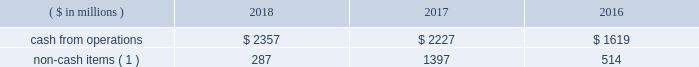We monitor the status of the capital markets and regularly evaluate the effect that changes in capital market conditions may have on our ability to execute our announced growth plans and fund our liquidity needs .
We expect to continue meeting part of our financing and liquidity needs primarily through commercial paper borrowings , issuances of senior notes , and access to long-term committed credit facilities .
If conditions in the lodging industry deteriorate , or if disruptions in the capital markets take place as they did in the immediate aftermath of both the 2008 worldwide financial crisis and the events of september 11 , 2001 , we may be unable to place some or all of our commercial paper on a temporary or extended basis and may have to rely more on borrowings under the credit facility , which we believe will be adequate to fund our liquidity needs , including repayment of debt obligations , but which may carry a higher cost than commercial paper .
Since we continue to have ample flexibility under the credit facility 2019s covenants , we expect that undrawn bank commitments under the credit facility will remain available to us even if business conditions were to deteriorate markedly .
Cash from operations cash from operations and non-cash items for the last three fiscal years are as follows: .
Non-cash items ( 1 ) 287 1397 514 ( 1 ) includes depreciation , amortization , share-based compensation , deferred income taxes , and contract investment amortization .
Our ratio of current assets to current liabilities was 0.4 to 1.0 at year-end 2018 and 0.5 to 1.0 at year-end 2017 .
We minimize working capital through cash management , strict credit-granting policies , and aggressive collection efforts .
We also have significant borrowing capacity under our credit facility should we need additional working capital .
Investing activities cash flows acquisition of a business , net of cash acquired .
Cash outflows of $ 2392 million in 2016 were due to the starwood combination .
See footnote 3 .
Dispositions and acquisitions for more information .
Capital expenditures and other investments .
We made capital expenditures of $ 556 million in 2018 , $ 240 million in 2017 , and $ 199 million in 2016 .
Capital expenditures in 2018 increased by $ 316 million compared to 2017 , primarily reflecting the acquisition of the sheraton grand phoenix , improvements to our worldwide systems , and net higher spending on several owned properties .
Capital expenditures in 2017 increased by $ 41 million compared to 2016 , primarily due to improvements to our worldwide systems and improvements to hotels acquired in the starwood combination .
We expect spending on capital expenditures and other investments will total approximately $ 500 million to $ 700 million for 2019 , including acquisitions , loan advances , equity and other investments , contract acquisition costs , and various capital expenditures ( including approximately $ 225 million for maintenance capital spending ) .
Over time , we have sold lodging properties , both completed and under development , subject to long-term management agreements .
The ability of third-party purchasers to raise the debt and equity capital necessary to acquire such properties depends in part on the perceived risks in the lodging industry and other constraints inherent in the capital markets .
We monitor the status of the capital markets and regularly evaluate the potential impact of changes in capital market conditions on our business operations .
In the starwood combination , we acquired various hotels and joint venture interests in hotels , most of which we have sold or are seeking to sell , and in 2018 , we acquired the sheraton grand phoenix , which we expect to renovate and sell subject to a long-term management agreement .
We also expect to continue making selective and opportunistic investments to add units to our lodging business , which may include property acquisitions , new construction , loans , guarantees , and noncontrolling equity investments .
Over time , we seek to minimize capital invested in our business through asset sales subject to long term operating or franchise agreements .
Fluctuations in the values of hotel real estate generally have little impact on our overall business results because : ( 1 ) we own less than one percent of hotels that we operate or franchise ; ( 2 ) management and franchise fees are generally based upon hotel revenues and profits rather than current hotel property values ; and ( 3 ) our management agreements generally do not terminate upon hotel sale or foreclosure .
Dispositions .
Property and asset sales generated $ 479 million cash proceeds in 2018 and $ 1418 million in 2017 .
See footnote 3 .
Dispositions and acquisitions for more information on dispositions. .
Non cash items represent what percent of cash from operations in 2018? 
Computations: (287 / 2357)
Answer: 0.12176. 